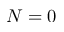Convert formula to latex. <formula><loc_0><loc_0><loc_500><loc_500>N = 0</formula> 